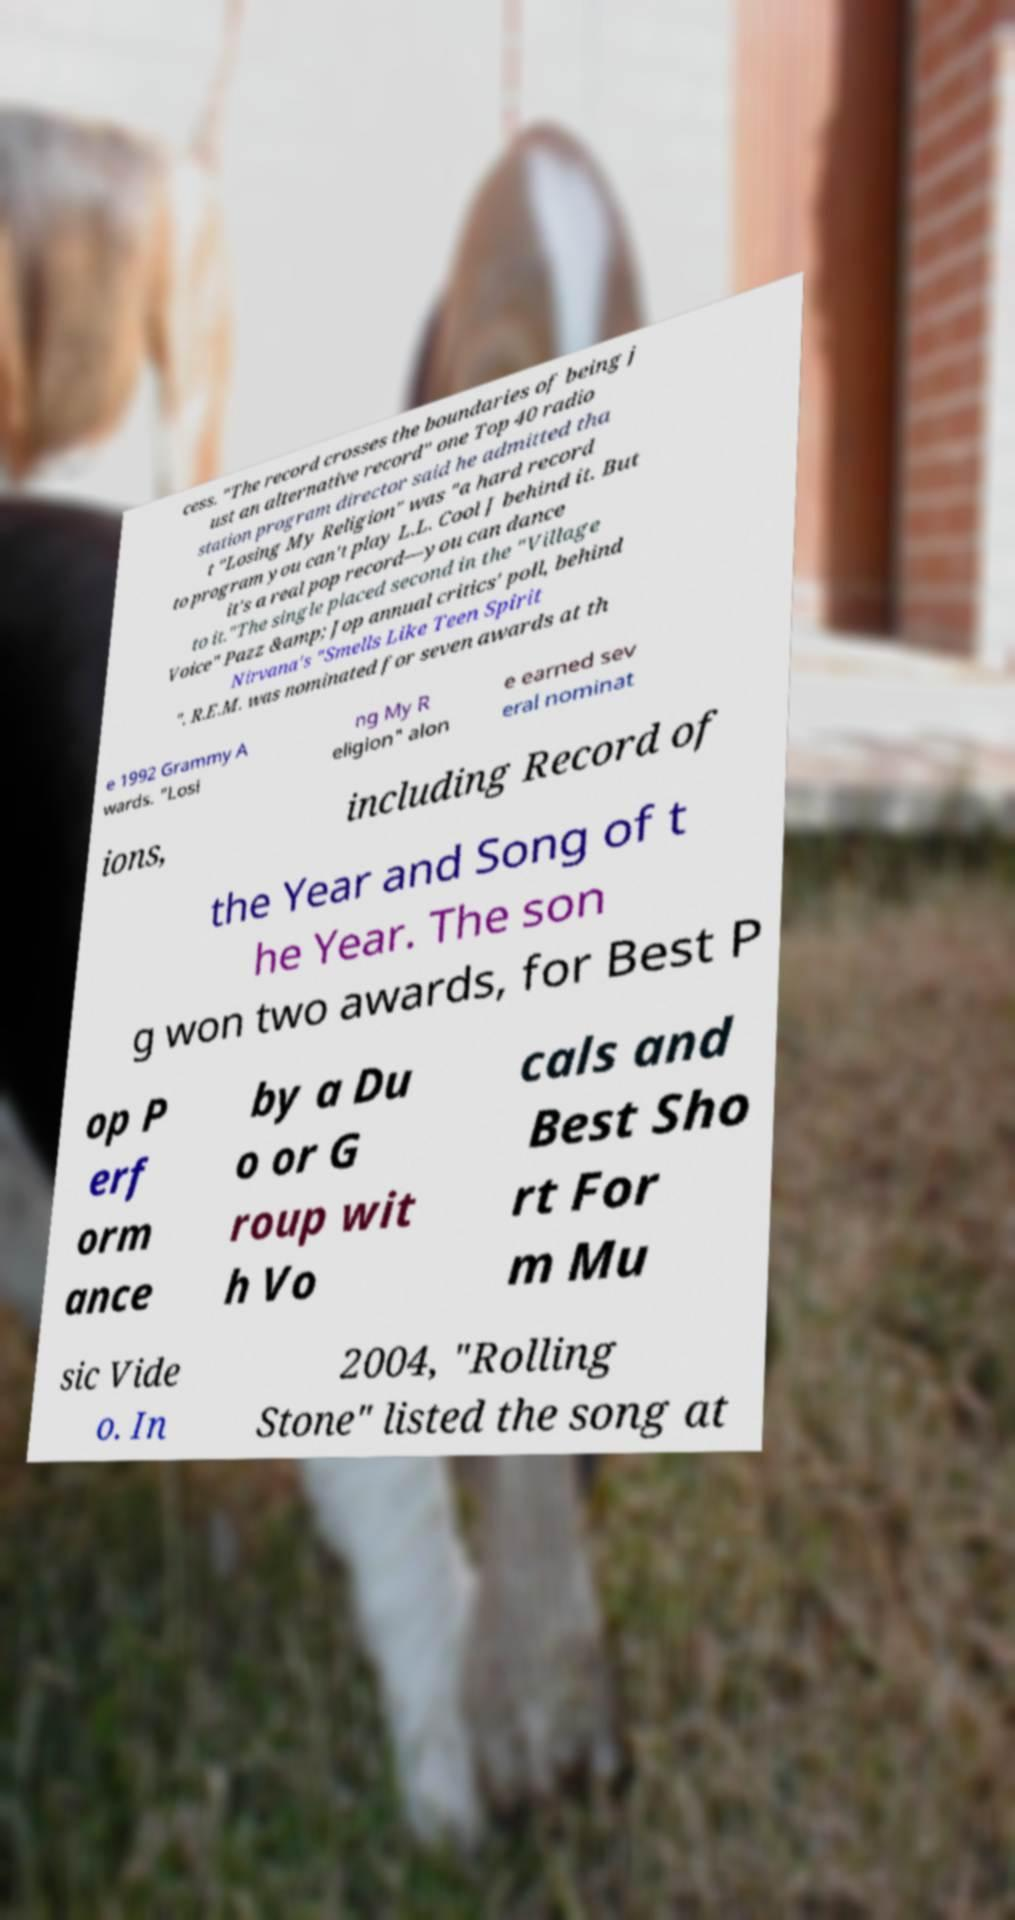Can you read and provide the text displayed in the image?This photo seems to have some interesting text. Can you extract and type it out for me? cess. "The record crosses the boundaries of being j ust an alternative record" one Top 40 radio station program director said he admitted tha t "Losing My Religion" was "a hard record to program you can't play L.L. Cool J behind it. But it's a real pop record—you can dance to it."The single placed second in the "Village Voice" Pazz &amp; Jop annual critics' poll, behind Nirvana's "Smells Like Teen Spirit ". R.E.M. was nominated for seven awards at th e 1992 Grammy A wards. "Losi ng My R eligion" alon e earned sev eral nominat ions, including Record of the Year and Song of t he Year. The son g won two awards, for Best P op P erf orm ance by a Du o or G roup wit h Vo cals and Best Sho rt For m Mu sic Vide o. In 2004, "Rolling Stone" listed the song at 